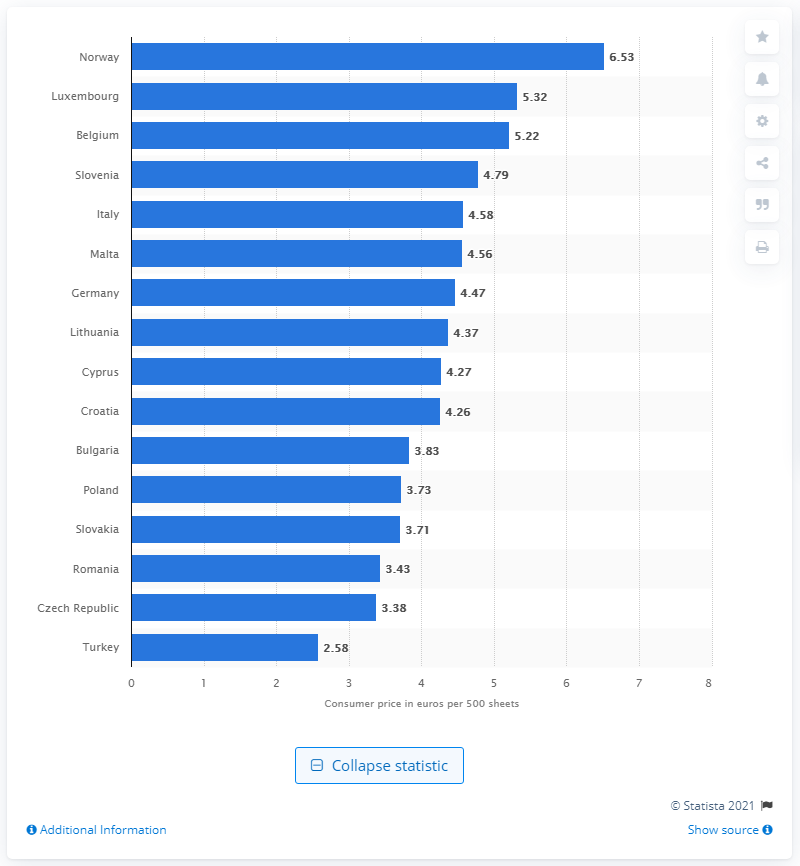Indicate a few pertinent items in this graphic. Norway had the highest price per 500 sheets among all countries. 